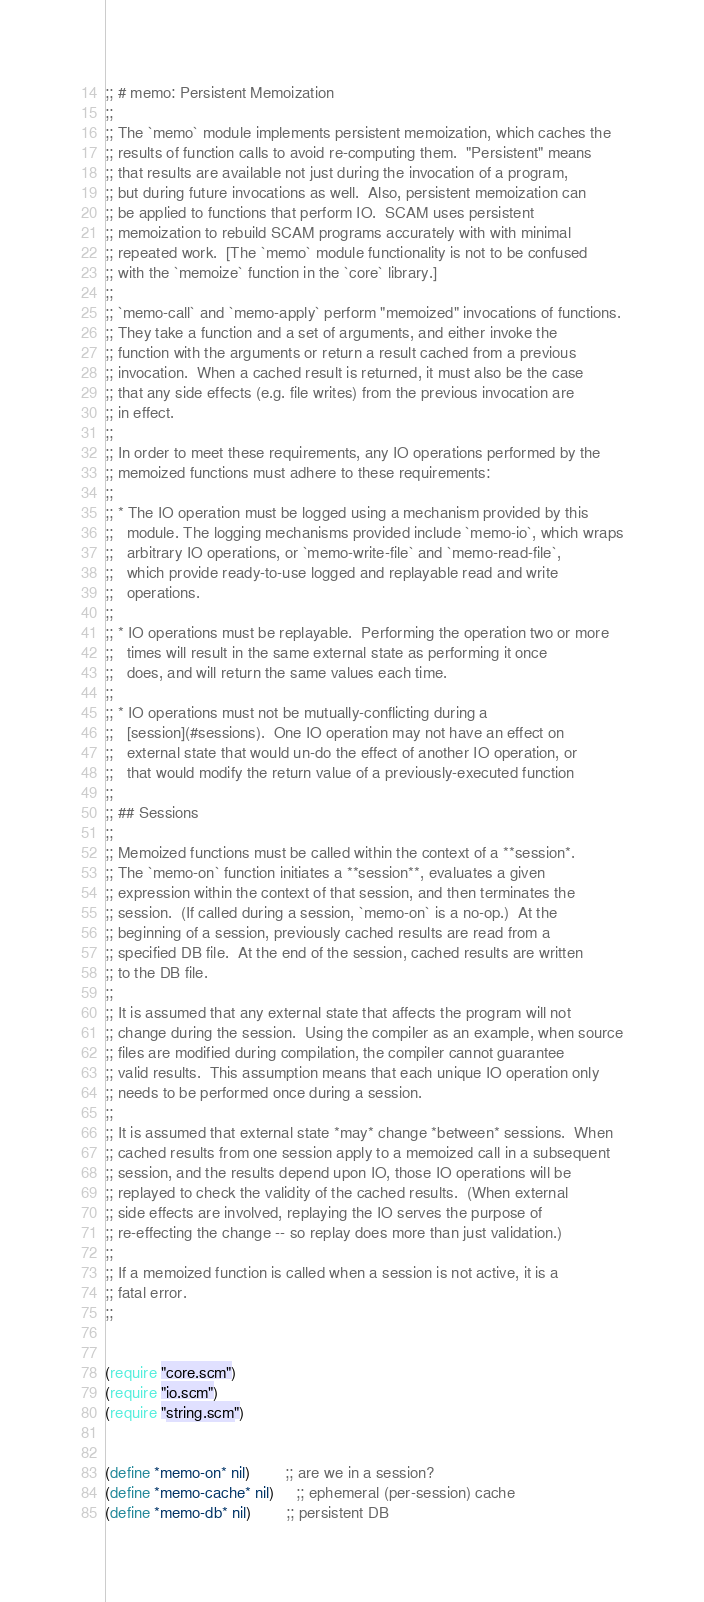Convert code to text. <code><loc_0><loc_0><loc_500><loc_500><_Scheme_>;; # memo: Persistent Memoization
;;
;; The `memo` module implements persistent memoization, which caches the
;; results of function calls to avoid re-computing them.  "Persistent" means
;; that results are available not just during the invocation of a program,
;; but during future invocations as well.  Also, persistent memoization can
;; be applied to functions that perform IO.  SCAM uses persistent
;; memoization to rebuild SCAM programs accurately with with minimal
;; repeated work.  [The `memo` module functionality is not to be confused
;; with the `memoize` function in the `core` library.]
;;
;; `memo-call` and `memo-apply` perform "memoized" invocations of functions.
;; They take a function and a set of arguments, and either invoke the
;; function with the arguments or return a result cached from a previous
;; invocation.  When a cached result is returned, it must also be the case
;; that any side effects (e.g. file writes) from the previous invocation are
;; in effect.
;;
;; In order to meet these requirements, any IO operations performed by the
;; memoized functions must adhere to these requirements:
;;
;; * The IO operation must be logged using a mechanism provided by this
;;   module. The logging mechanisms provided include `memo-io`, which wraps
;;   arbitrary IO operations, or `memo-write-file` and `memo-read-file`,
;;   which provide ready-to-use logged and replayable read and write
;;   operations.
;;
;; * IO operations must be replayable.  Performing the operation two or more
;;   times will result in the same external state as performing it once
;;   does, and will return the same values each time.
;;
;; * IO operations must not be mutually-conflicting during a
;;   [session](#sessions).  One IO operation may not have an effect on
;;   external state that would un-do the effect of another IO operation, or
;;   that would modify the return value of a previously-executed function
;;
;; ## Sessions
;;
;; Memoized functions must be called within the context of a **session*.
;; The `memo-on` function initiates a **session**, evaluates a given
;; expression within the context of that session, and then terminates the
;; session.  (If called during a session, `memo-on` is a no-op.)  At the
;; beginning of a session, previously cached results are read from a
;; specified DB file.  At the end of the session, cached results are written
;; to the DB file.
;;
;; It is assumed that any external state that affects the program will not
;; change during the session.  Using the compiler as an example, when source
;; files are modified during compilation, the compiler cannot guarantee
;; valid results.  This assumption means that each unique IO operation only
;; needs to be performed once during a session.
;;
;; It is assumed that external state *may* change *between* sessions.  When
;; cached results from one session apply to a memoized call in a subsequent
;; session, and the results depend upon IO, those IO operations will be
;; replayed to check the validity of the cached results.  (When external
;; side effects are involved, replaying the IO serves the purpose of
;; re-effecting the change -- so replay does more than just validation.)
;;
;; If a memoized function is called when a session is not active, it is a
;; fatal error.
;;


(require "core.scm")
(require "io.scm")
(require "string.scm")


(define *memo-on* nil)        ;; are we in a session?
(define *memo-cache* nil)     ;; ephemeral (per-session) cache
(define *memo-db* nil)        ;; persistent DB</code> 